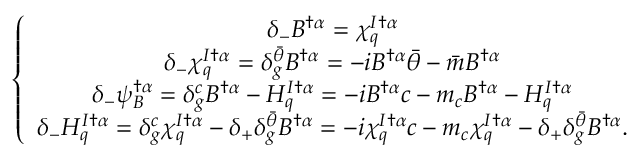Convert formula to latex. <formula><loc_0><loc_0><loc_500><loc_500>\left \{ \begin{array} { c } { { \delta _ { - } B ^ { \dagger \alpha } = \chi _ { q } ^ { I \dagger \alpha } } } \\ { { \delta _ { - } \chi _ { q } ^ { I \dagger \alpha } = \delta _ { g } ^ { \bar { \theta } } B ^ { \dagger \alpha } = - i B ^ { \dagger \alpha } { \bar { \theta } } - { \bar { m } } B ^ { \dagger \alpha } } } \\ { { \delta _ { - } \psi _ { B } ^ { \dagger \alpha } = \delta _ { g } ^ { c } B ^ { \dagger \alpha } - H _ { q } ^ { I \dagger \alpha } = - i B ^ { \dagger \alpha } c - m _ { c } B ^ { \dagger \alpha } - H _ { q } ^ { I \dagger \alpha } } } \\ { { \delta _ { - } H _ { q } ^ { I \dagger \alpha } = \delta _ { g } ^ { c } \chi _ { q } ^ { I \dagger \alpha } - \delta _ { + } \delta _ { g } ^ { \bar { \theta } } B ^ { \dagger \alpha } = - i \chi _ { q } ^ { I \dagger \alpha } c - m _ { c } \chi _ { q } ^ { I \dagger \alpha } - \delta _ { + } \delta _ { g } ^ { \bar { \theta } } B ^ { \dagger \alpha } . } } \end{array}</formula> 